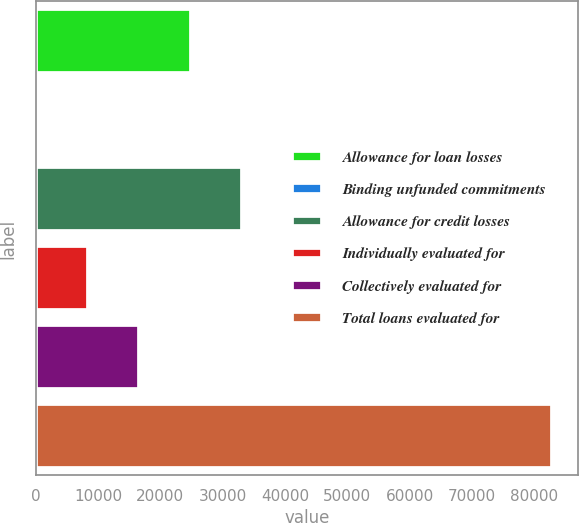Convert chart. <chart><loc_0><loc_0><loc_500><loc_500><bar_chart><fcel>Allowance for loan losses<fcel>Binding unfunded commitments<fcel>Allowance for credit losses<fcel>Individually evaluated for<fcel>Collectively evaluated for<fcel>Total loans evaluated for<nl><fcel>24894.2<fcel>50<fcel>33175.6<fcel>8331.4<fcel>16612.8<fcel>82864<nl></chart> 